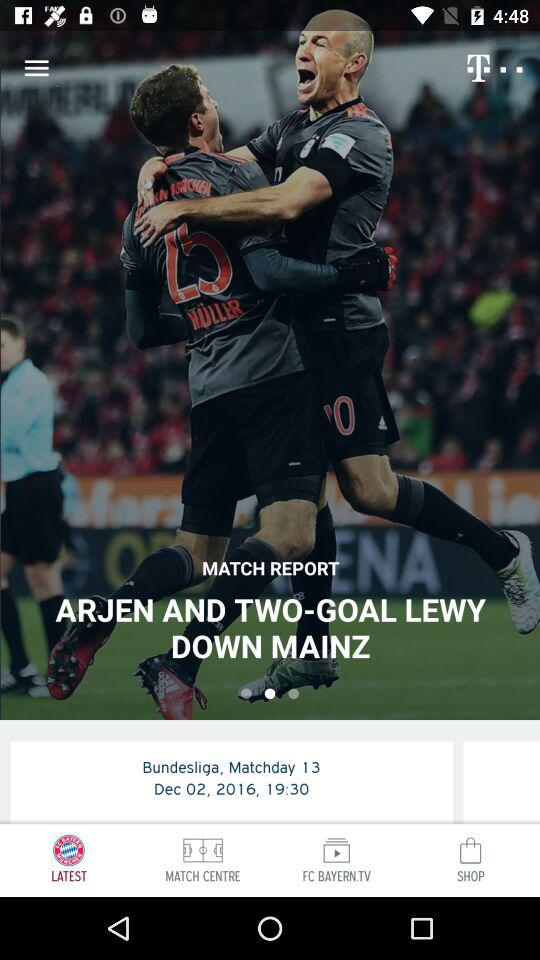What is the time of the match? The time of the match is 19:30. 